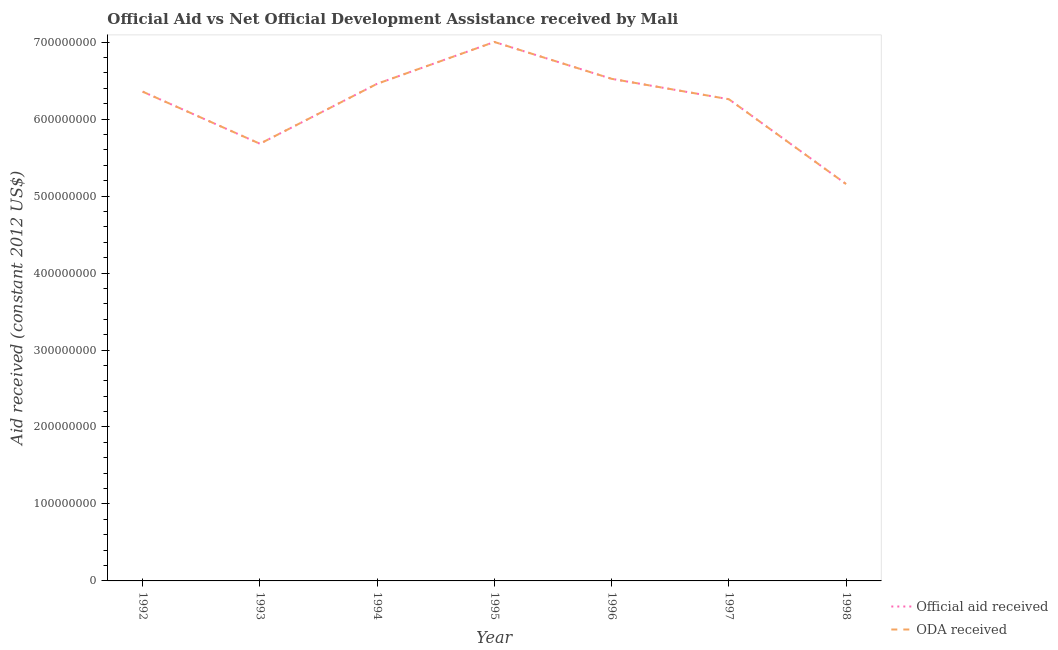How many different coloured lines are there?
Offer a very short reply. 2. What is the oda received in 1993?
Your response must be concise. 5.68e+08. Across all years, what is the maximum oda received?
Offer a terse response. 7.00e+08. Across all years, what is the minimum official aid received?
Ensure brevity in your answer.  5.16e+08. In which year was the official aid received maximum?
Give a very brief answer. 1995. What is the total official aid received in the graph?
Ensure brevity in your answer.  4.34e+09. What is the difference between the oda received in 1992 and that in 1993?
Offer a terse response. 6.77e+07. What is the difference between the official aid received in 1998 and the oda received in 1996?
Keep it short and to the point. -1.37e+08. What is the average oda received per year?
Make the answer very short. 6.21e+08. In the year 1994, what is the difference between the oda received and official aid received?
Offer a terse response. 0. What is the ratio of the official aid received in 1992 to that in 1993?
Offer a terse response. 1.12. What is the difference between the highest and the second highest oda received?
Keep it short and to the point. 4.79e+07. What is the difference between the highest and the lowest oda received?
Offer a very short reply. 1.85e+08. Is the oda received strictly greater than the official aid received over the years?
Keep it short and to the point. No. Is the oda received strictly less than the official aid received over the years?
Your answer should be compact. No. How many lines are there?
Offer a very short reply. 2. How many years are there in the graph?
Provide a short and direct response. 7. What is the difference between two consecutive major ticks on the Y-axis?
Your answer should be compact. 1.00e+08. Does the graph contain any zero values?
Make the answer very short. No. How many legend labels are there?
Keep it short and to the point. 2. What is the title of the graph?
Provide a succinct answer. Official Aid vs Net Official Development Assistance received by Mali . Does "Goods and services" appear as one of the legend labels in the graph?
Provide a short and direct response. No. What is the label or title of the X-axis?
Provide a short and direct response. Year. What is the label or title of the Y-axis?
Your answer should be compact. Aid received (constant 2012 US$). What is the Aid received (constant 2012 US$) of Official aid received in 1992?
Keep it short and to the point. 6.36e+08. What is the Aid received (constant 2012 US$) of ODA received in 1992?
Provide a short and direct response. 6.36e+08. What is the Aid received (constant 2012 US$) of Official aid received in 1993?
Provide a short and direct response. 5.68e+08. What is the Aid received (constant 2012 US$) in ODA received in 1993?
Your answer should be very brief. 5.68e+08. What is the Aid received (constant 2012 US$) of Official aid received in 1994?
Provide a succinct answer. 6.46e+08. What is the Aid received (constant 2012 US$) of ODA received in 1994?
Provide a succinct answer. 6.46e+08. What is the Aid received (constant 2012 US$) of Official aid received in 1995?
Give a very brief answer. 7.00e+08. What is the Aid received (constant 2012 US$) of ODA received in 1995?
Keep it short and to the point. 7.00e+08. What is the Aid received (constant 2012 US$) in Official aid received in 1996?
Offer a terse response. 6.52e+08. What is the Aid received (constant 2012 US$) in ODA received in 1996?
Your answer should be very brief. 6.52e+08. What is the Aid received (constant 2012 US$) of Official aid received in 1997?
Ensure brevity in your answer.  6.26e+08. What is the Aid received (constant 2012 US$) in ODA received in 1997?
Provide a succinct answer. 6.26e+08. What is the Aid received (constant 2012 US$) of Official aid received in 1998?
Make the answer very short. 5.16e+08. What is the Aid received (constant 2012 US$) in ODA received in 1998?
Give a very brief answer. 5.16e+08. Across all years, what is the maximum Aid received (constant 2012 US$) in Official aid received?
Make the answer very short. 7.00e+08. Across all years, what is the maximum Aid received (constant 2012 US$) in ODA received?
Keep it short and to the point. 7.00e+08. Across all years, what is the minimum Aid received (constant 2012 US$) in Official aid received?
Give a very brief answer. 5.16e+08. Across all years, what is the minimum Aid received (constant 2012 US$) in ODA received?
Ensure brevity in your answer.  5.16e+08. What is the total Aid received (constant 2012 US$) in Official aid received in the graph?
Offer a very short reply. 4.34e+09. What is the total Aid received (constant 2012 US$) in ODA received in the graph?
Make the answer very short. 4.34e+09. What is the difference between the Aid received (constant 2012 US$) of Official aid received in 1992 and that in 1993?
Ensure brevity in your answer.  6.77e+07. What is the difference between the Aid received (constant 2012 US$) of ODA received in 1992 and that in 1993?
Make the answer very short. 6.77e+07. What is the difference between the Aid received (constant 2012 US$) of Official aid received in 1992 and that in 1994?
Your answer should be very brief. -1.02e+07. What is the difference between the Aid received (constant 2012 US$) of ODA received in 1992 and that in 1994?
Offer a very short reply. -1.02e+07. What is the difference between the Aid received (constant 2012 US$) of Official aid received in 1992 and that in 1995?
Offer a terse response. -6.45e+07. What is the difference between the Aid received (constant 2012 US$) of ODA received in 1992 and that in 1995?
Offer a very short reply. -6.45e+07. What is the difference between the Aid received (constant 2012 US$) of Official aid received in 1992 and that in 1996?
Provide a short and direct response. -1.67e+07. What is the difference between the Aid received (constant 2012 US$) in ODA received in 1992 and that in 1996?
Offer a very short reply. -1.67e+07. What is the difference between the Aid received (constant 2012 US$) of Official aid received in 1992 and that in 1997?
Make the answer very short. 9.86e+06. What is the difference between the Aid received (constant 2012 US$) of ODA received in 1992 and that in 1997?
Keep it short and to the point. 9.86e+06. What is the difference between the Aid received (constant 2012 US$) of Official aid received in 1992 and that in 1998?
Offer a terse response. 1.20e+08. What is the difference between the Aid received (constant 2012 US$) in ODA received in 1992 and that in 1998?
Provide a short and direct response. 1.20e+08. What is the difference between the Aid received (constant 2012 US$) in Official aid received in 1993 and that in 1994?
Offer a very short reply. -7.79e+07. What is the difference between the Aid received (constant 2012 US$) in ODA received in 1993 and that in 1994?
Provide a short and direct response. -7.79e+07. What is the difference between the Aid received (constant 2012 US$) in Official aid received in 1993 and that in 1995?
Ensure brevity in your answer.  -1.32e+08. What is the difference between the Aid received (constant 2012 US$) of ODA received in 1993 and that in 1995?
Provide a succinct answer. -1.32e+08. What is the difference between the Aid received (constant 2012 US$) of Official aid received in 1993 and that in 1996?
Your answer should be compact. -8.44e+07. What is the difference between the Aid received (constant 2012 US$) of ODA received in 1993 and that in 1996?
Provide a short and direct response. -8.44e+07. What is the difference between the Aid received (constant 2012 US$) in Official aid received in 1993 and that in 1997?
Give a very brief answer. -5.78e+07. What is the difference between the Aid received (constant 2012 US$) of ODA received in 1993 and that in 1997?
Offer a very short reply. -5.78e+07. What is the difference between the Aid received (constant 2012 US$) of Official aid received in 1993 and that in 1998?
Your answer should be very brief. 5.24e+07. What is the difference between the Aid received (constant 2012 US$) of ODA received in 1993 and that in 1998?
Your answer should be very brief. 5.24e+07. What is the difference between the Aid received (constant 2012 US$) of Official aid received in 1994 and that in 1995?
Your response must be concise. -5.43e+07. What is the difference between the Aid received (constant 2012 US$) of ODA received in 1994 and that in 1995?
Your answer should be very brief. -5.43e+07. What is the difference between the Aid received (constant 2012 US$) of Official aid received in 1994 and that in 1996?
Your answer should be very brief. -6.43e+06. What is the difference between the Aid received (constant 2012 US$) in ODA received in 1994 and that in 1996?
Offer a terse response. -6.43e+06. What is the difference between the Aid received (constant 2012 US$) in Official aid received in 1994 and that in 1997?
Provide a succinct answer. 2.01e+07. What is the difference between the Aid received (constant 2012 US$) in ODA received in 1994 and that in 1997?
Your answer should be compact. 2.01e+07. What is the difference between the Aid received (constant 2012 US$) of Official aid received in 1994 and that in 1998?
Offer a very short reply. 1.30e+08. What is the difference between the Aid received (constant 2012 US$) of ODA received in 1994 and that in 1998?
Offer a very short reply. 1.30e+08. What is the difference between the Aid received (constant 2012 US$) of Official aid received in 1995 and that in 1996?
Offer a very short reply. 4.79e+07. What is the difference between the Aid received (constant 2012 US$) in ODA received in 1995 and that in 1996?
Provide a short and direct response. 4.79e+07. What is the difference between the Aid received (constant 2012 US$) of Official aid received in 1995 and that in 1997?
Your answer should be very brief. 7.44e+07. What is the difference between the Aid received (constant 2012 US$) of ODA received in 1995 and that in 1997?
Keep it short and to the point. 7.44e+07. What is the difference between the Aid received (constant 2012 US$) in Official aid received in 1995 and that in 1998?
Ensure brevity in your answer.  1.85e+08. What is the difference between the Aid received (constant 2012 US$) in ODA received in 1995 and that in 1998?
Offer a terse response. 1.85e+08. What is the difference between the Aid received (constant 2012 US$) of Official aid received in 1996 and that in 1997?
Make the answer very short. 2.65e+07. What is the difference between the Aid received (constant 2012 US$) of ODA received in 1996 and that in 1997?
Your response must be concise. 2.65e+07. What is the difference between the Aid received (constant 2012 US$) of Official aid received in 1996 and that in 1998?
Make the answer very short. 1.37e+08. What is the difference between the Aid received (constant 2012 US$) of ODA received in 1996 and that in 1998?
Your answer should be compact. 1.37e+08. What is the difference between the Aid received (constant 2012 US$) in Official aid received in 1997 and that in 1998?
Make the answer very short. 1.10e+08. What is the difference between the Aid received (constant 2012 US$) in ODA received in 1997 and that in 1998?
Offer a terse response. 1.10e+08. What is the difference between the Aid received (constant 2012 US$) of Official aid received in 1992 and the Aid received (constant 2012 US$) of ODA received in 1993?
Provide a succinct answer. 6.77e+07. What is the difference between the Aid received (constant 2012 US$) of Official aid received in 1992 and the Aid received (constant 2012 US$) of ODA received in 1994?
Give a very brief answer. -1.02e+07. What is the difference between the Aid received (constant 2012 US$) of Official aid received in 1992 and the Aid received (constant 2012 US$) of ODA received in 1995?
Your answer should be very brief. -6.45e+07. What is the difference between the Aid received (constant 2012 US$) in Official aid received in 1992 and the Aid received (constant 2012 US$) in ODA received in 1996?
Make the answer very short. -1.67e+07. What is the difference between the Aid received (constant 2012 US$) in Official aid received in 1992 and the Aid received (constant 2012 US$) in ODA received in 1997?
Keep it short and to the point. 9.86e+06. What is the difference between the Aid received (constant 2012 US$) in Official aid received in 1992 and the Aid received (constant 2012 US$) in ODA received in 1998?
Offer a very short reply. 1.20e+08. What is the difference between the Aid received (constant 2012 US$) in Official aid received in 1993 and the Aid received (constant 2012 US$) in ODA received in 1994?
Give a very brief answer. -7.79e+07. What is the difference between the Aid received (constant 2012 US$) of Official aid received in 1993 and the Aid received (constant 2012 US$) of ODA received in 1995?
Offer a very short reply. -1.32e+08. What is the difference between the Aid received (constant 2012 US$) of Official aid received in 1993 and the Aid received (constant 2012 US$) of ODA received in 1996?
Give a very brief answer. -8.44e+07. What is the difference between the Aid received (constant 2012 US$) of Official aid received in 1993 and the Aid received (constant 2012 US$) of ODA received in 1997?
Your answer should be compact. -5.78e+07. What is the difference between the Aid received (constant 2012 US$) in Official aid received in 1993 and the Aid received (constant 2012 US$) in ODA received in 1998?
Provide a short and direct response. 5.24e+07. What is the difference between the Aid received (constant 2012 US$) in Official aid received in 1994 and the Aid received (constant 2012 US$) in ODA received in 1995?
Make the answer very short. -5.43e+07. What is the difference between the Aid received (constant 2012 US$) in Official aid received in 1994 and the Aid received (constant 2012 US$) in ODA received in 1996?
Your response must be concise. -6.43e+06. What is the difference between the Aid received (constant 2012 US$) in Official aid received in 1994 and the Aid received (constant 2012 US$) in ODA received in 1997?
Offer a terse response. 2.01e+07. What is the difference between the Aid received (constant 2012 US$) of Official aid received in 1994 and the Aid received (constant 2012 US$) of ODA received in 1998?
Offer a very short reply. 1.30e+08. What is the difference between the Aid received (constant 2012 US$) of Official aid received in 1995 and the Aid received (constant 2012 US$) of ODA received in 1996?
Your response must be concise. 4.79e+07. What is the difference between the Aid received (constant 2012 US$) in Official aid received in 1995 and the Aid received (constant 2012 US$) in ODA received in 1997?
Offer a terse response. 7.44e+07. What is the difference between the Aid received (constant 2012 US$) of Official aid received in 1995 and the Aid received (constant 2012 US$) of ODA received in 1998?
Offer a terse response. 1.85e+08. What is the difference between the Aid received (constant 2012 US$) of Official aid received in 1996 and the Aid received (constant 2012 US$) of ODA received in 1997?
Keep it short and to the point. 2.65e+07. What is the difference between the Aid received (constant 2012 US$) of Official aid received in 1996 and the Aid received (constant 2012 US$) of ODA received in 1998?
Your answer should be compact. 1.37e+08. What is the difference between the Aid received (constant 2012 US$) of Official aid received in 1997 and the Aid received (constant 2012 US$) of ODA received in 1998?
Your response must be concise. 1.10e+08. What is the average Aid received (constant 2012 US$) in Official aid received per year?
Give a very brief answer. 6.21e+08. What is the average Aid received (constant 2012 US$) in ODA received per year?
Your answer should be very brief. 6.21e+08. In the year 1993, what is the difference between the Aid received (constant 2012 US$) of Official aid received and Aid received (constant 2012 US$) of ODA received?
Offer a very short reply. 0. In the year 1997, what is the difference between the Aid received (constant 2012 US$) in Official aid received and Aid received (constant 2012 US$) in ODA received?
Provide a succinct answer. 0. In the year 1998, what is the difference between the Aid received (constant 2012 US$) of Official aid received and Aid received (constant 2012 US$) of ODA received?
Your answer should be compact. 0. What is the ratio of the Aid received (constant 2012 US$) of Official aid received in 1992 to that in 1993?
Your answer should be compact. 1.12. What is the ratio of the Aid received (constant 2012 US$) of ODA received in 1992 to that in 1993?
Offer a terse response. 1.12. What is the ratio of the Aid received (constant 2012 US$) of Official aid received in 1992 to that in 1994?
Your answer should be compact. 0.98. What is the ratio of the Aid received (constant 2012 US$) in ODA received in 1992 to that in 1994?
Keep it short and to the point. 0.98. What is the ratio of the Aid received (constant 2012 US$) in Official aid received in 1992 to that in 1995?
Give a very brief answer. 0.91. What is the ratio of the Aid received (constant 2012 US$) in ODA received in 1992 to that in 1995?
Provide a short and direct response. 0.91. What is the ratio of the Aid received (constant 2012 US$) of Official aid received in 1992 to that in 1996?
Ensure brevity in your answer.  0.97. What is the ratio of the Aid received (constant 2012 US$) of ODA received in 1992 to that in 1996?
Ensure brevity in your answer.  0.97. What is the ratio of the Aid received (constant 2012 US$) of Official aid received in 1992 to that in 1997?
Your answer should be compact. 1.02. What is the ratio of the Aid received (constant 2012 US$) of ODA received in 1992 to that in 1997?
Offer a very short reply. 1.02. What is the ratio of the Aid received (constant 2012 US$) in Official aid received in 1992 to that in 1998?
Keep it short and to the point. 1.23. What is the ratio of the Aid received (constant 2012 US$) in ODA received in 1992 to that in 1998?
Offer a very short reply. 1.23. What is the ratio of the Aid received (constant 2012 US$) in Official aid received in 1993 to that in 1994?
Provide a short and direct response. 0.88. What is the ratio of the Aid received (constant 2012 US$) in ODA received in 1993 to that in 1994?
Your response must be concise. 0.88. What is the ratio of the Aid received (constant 2012 US$) of Official aid received in 1993 to that in 1995?
Make the answer very short. 0.81. What is the ratio of the Aid received (constant 2012 US$) of ODA received in 1993 to that in 1995?
Offer a terse response. 0.81. What is the ratio of the Aid received (constant 2012 US$) in Official aid received in 1993 to that in 1996?
Keep it short and to the point. 0.87. What is the ratio of the Aid received (constant 2012 US$) of ODA received in 1993 to that in 1996?
Your answer should be very brief. 0.87. What is the ratio of the Aid received (constant 2012 US$) of Official aid received in 1993 to that in 1997?
Your response must be concise. 0.91. What is the ratio of the Aid received (constant 2012 US$) of ODA received in 1993 to that in 1997?
Offer a terse response. 0.91. What is the ratio of the Aid received (constant 2012 US$) in Official aid received in 1993 to that in 1998?
Your answer should be compact. 1.1. What is the ratio of the Aid received (constant 2012 US$) in ODA received in 1993 to that in 1998?
Provide a succinct answer. 1.1. What is the ratio of the Aid received (constant 2012 US$) of Official aid received in 1994 to that in 1995?
Offer a very short reply. 0.92. What is the ratio of the Aid received (constant 2012 US$) of ODA received in 1994 to that in 1995?
Offer a terse response. 0.92. What is the ratio of the Aid received (constant 2012 US$) of Official aid received in 1994 to that in 1997?
Your answer should be compact. 1.03. What is the ratio of the Aid received (constant 2012 US$) of ODA received in 1994 to that in 1997?
Provide a short and direct response. 1.03. What is the ratio of the Aid received (constant 2012 US$) of Official aid received in 1994 to that in 1998?
Your answer should be very brief. 1.25. What is the ratio of the Aid received (constant 2012 US$) of ODA received in 1994 to that in 1998?
Your response must be concise. 1.25. What is the ratio of the Aid received (constant 2012 US$) of Official aid received in 1995 to that in 1996?
Provide a succinct answer. 1.07. What is the ratio of the Aid received (constant 2012 US$) in ODA received in 1995 to that in 1996?
Your answer should be very brief. 1.07. What is the ratio of the Aid received (constant 2012 US$) in Official aid received in 1995 to that in 1997?
Ensure brevity in your answer.  1.12. What is the ratio of the Aid received (constant 2012 US$) of ODA received in 1995 to that in 1997?
Offer a very short reply. 1.12. What is the ratio of the Aid received (constant 2012 US$) of Official aid received in 1995 to that in 1998?
Make the answer very short. 1.36. What is the ratio of the Aid received (constant 2012 US$) of ODA received in 1995 to that in 1998?
Keep it short and to the point. 1.36. What is the ratio of the Aid received (constant 2012 US$) in Official aid received in 1996 to that in 1997?
Your response must be concise. 1.04. What is the ratio of the Aid received (constant 2012 US$) in ODA received in 1996 to that in 1997?
Ensure brevity in your answer.  1.04. What is the ratio of the Aid received (constant 2012 US$) in Official aid received in 1996 to that in 1998?
Your answer should be compact. 1.27. What is the ratio of the Aid received (constant 2012 US$) of ODA received in 1996 to that in 1998?
Your answer should be compact. 1.27. What is the ratio of the Aid received (constant 2012 US$) in Official aid received in 1997 to that in 1998?
Ensure brevity in your answer.  1.21. What is the ratio of the Aid received (constant 2012 US$) of ODA received in 1997 to that in 1998?
Keep it short and to the point. 1.21. What is the difference between the highest and the second highest Aid received (constant 2012 US$) in Official aid received?
Ensure brevity in your answer.  4.79e+07. What is the difference between the highest and the second highest Aid received (constant 2012 US$) in ODA received?
Offer a terse response. 4.79e+07. What is the difference between the highest and the lowest Aid received (constant 2012 US$) of Official aid received?
Offer a very short reply. 1.85e+08. What is the difference between the highest and the lowest Aid received (constant 2012 US$) of ODA received?
Your answer should be compact. 1.85e+08. 